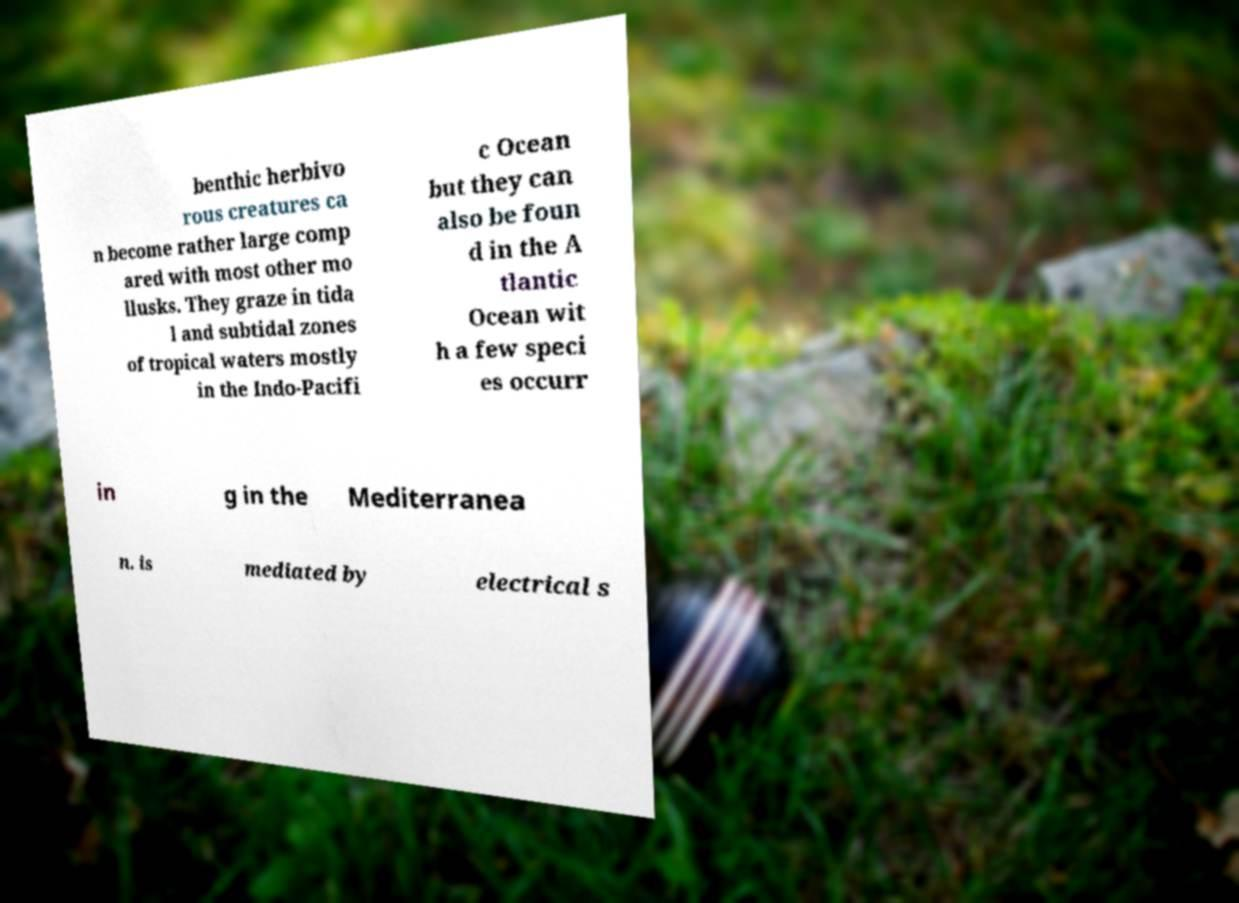I need the written content from this picture converted into text. Can you do that? benthic herbivo rous creatures ca n become rather large comp ared with most other mo llusks. They graze in tida l and subtidal zones of tropical waters mostly in the Indo-Pacifi c Ocean but they can also be foun d in the A tlantic Ocean wit h a few speci es occurr in g in the Mediterranea n. is mediated by electrical s 